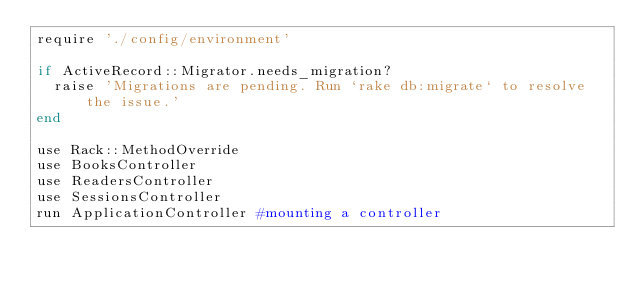Convert code to text. <code><loc_0><loc_0><loc_500><loc_500><_Ruby_>require './config/environment'

if ActiveRecord::Migrator.needs_migration?
  raise 'Migrations are pending. Run `rake db:migrate` to resolve the issue.'
end

use Rack::MethodOverride
use BooksController
use ReadersController
use SessionsController
run ApplicationController #mounting a controller
</code> 